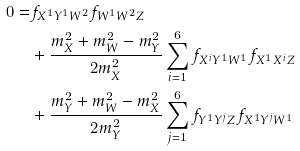Convert formula to latex. <formula><loc_0><loc_0><loc_500><loc_500>0 = & f _ { X ^ { 1 } Y ^ { 1 } W ^ { 2 } } f _ { W ^ { 1 } W ^ { 2 } Z } \\ & + \frac { m _ { X } ^ { 2 } + m _ { W } ^ { 2 } - m _ { Y } ^ { 2 } } { 2 m _ { X } ^ { 2 } } \sum _ { i = 1 } ^ { 6 } f _ { X ^ { i } Y ^ { 1 } W ^ { 1 } } f _ { X ^ { 1 } X ^ { i } Z } \\ & + \frac { m _ { Y } ^ { 2 } + m _ { W } ^ { 2 } - m _ { X } ^ { 2 } } { 2 m _ { Y } ^ { 2 } } \sum _ { j = 1 } ^ { 6 } f _ { Y ^ { 1 } Y ^ { j } Z } f _ { X ^ { 1 } Y ^ { j } W ^ { 1 } }</formula> 